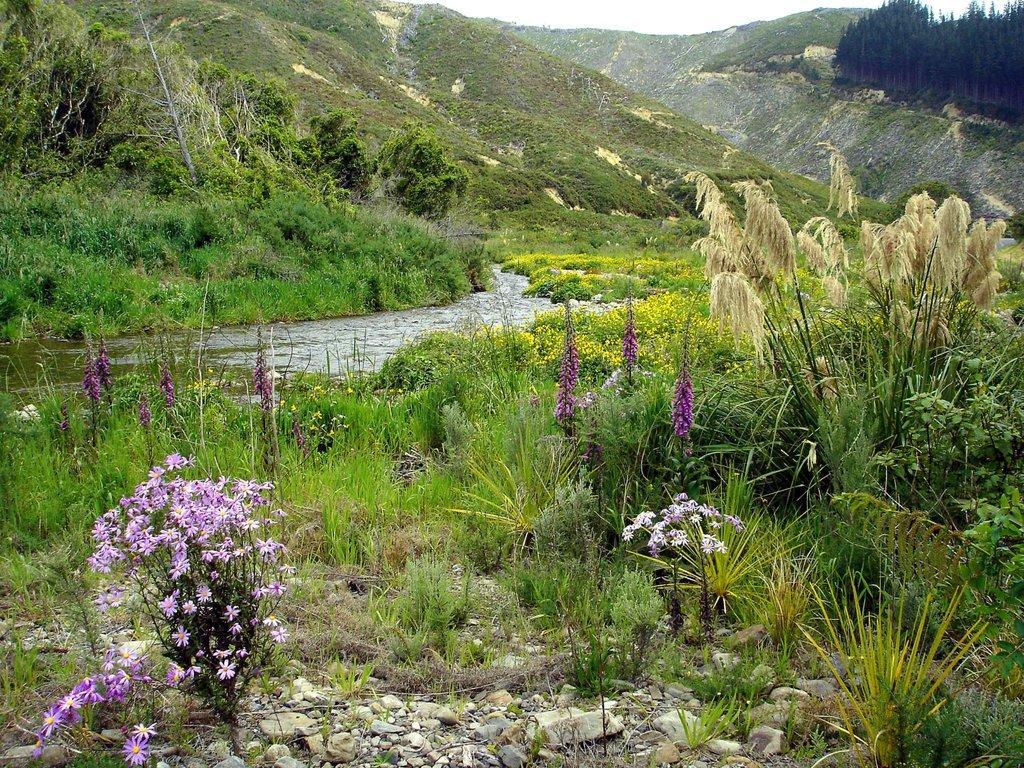Please provide a concise description of this image. In this image I can see an open grass ground and in the front I can see number of flowers. I can also see water in the centre and in the background I can see number of trees. 